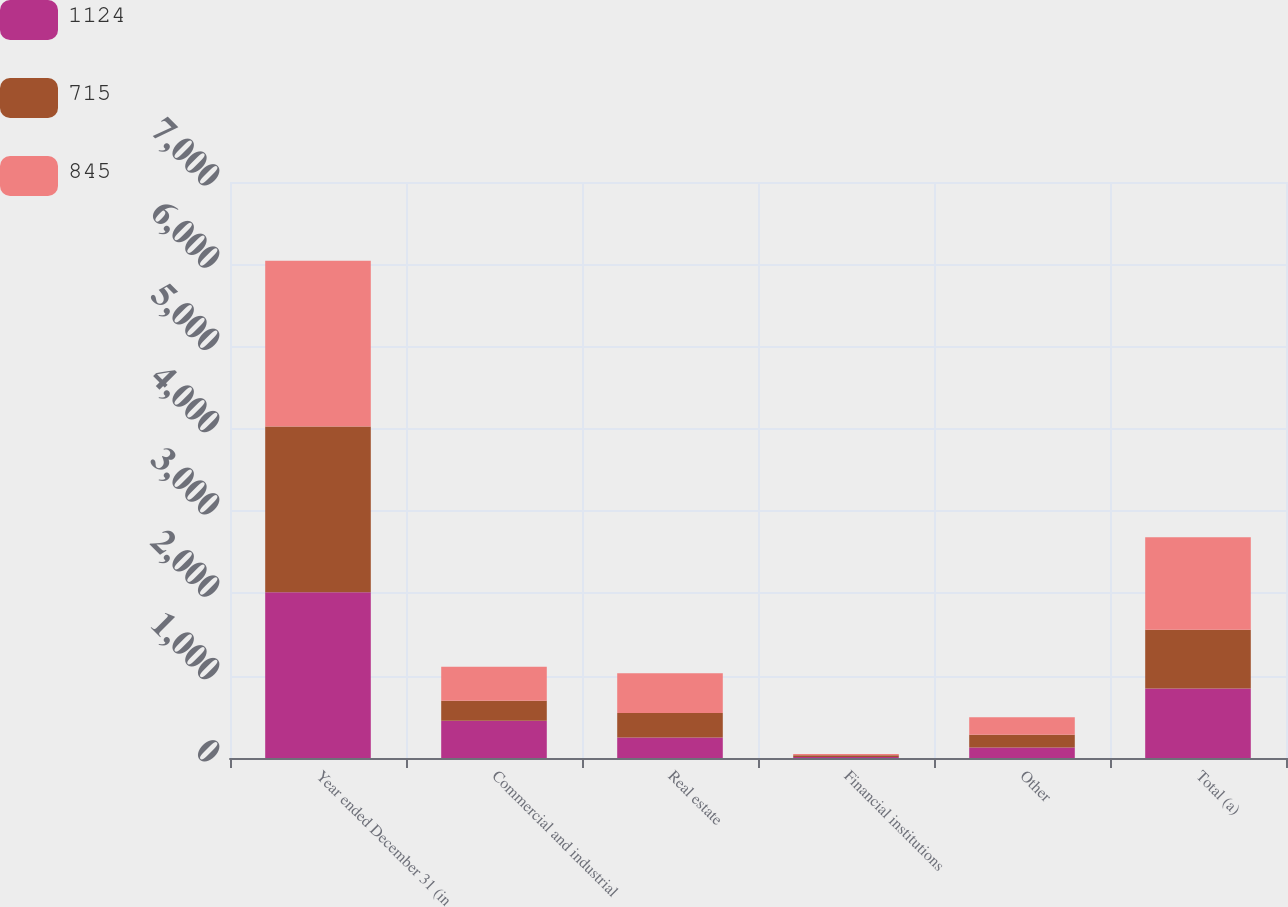Convert chart. <chart><loc_0><loc_0><loc_500><loc_500><stacked_bar_chart><ecel><fcel>Year ended December 31 (in<fcel>Commercial and industrial<fcel>Real estate<fcel>Financial institutions<fcel>Other<fcel>Total (a)<nl><fcel>1124<fcel>2015<fcel>453<fcel>250<fcel>13<fcel>129<fcel>845<nl><fcel>715<fcel>2014<fcel>243<fcel>297<fcel>20<fcel>155<fcel>715<nl><fcel>845<fcel>2013<fcel>412<fcel>484<fcel>17<fcel>211<fcel>1124<nl></chart> 